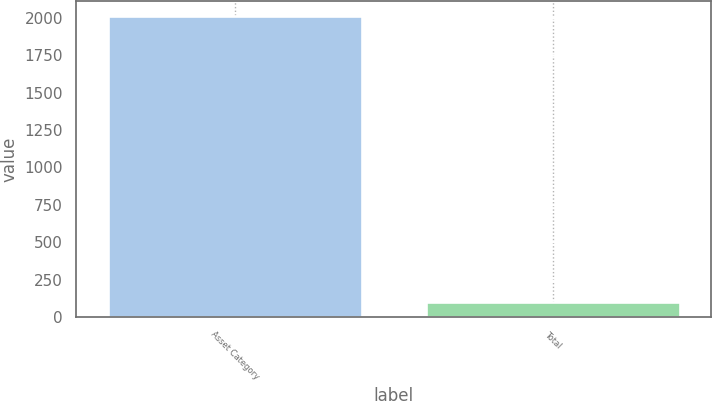<chart> <loc_0><loc_0><loc_500><loc_500><bar_chart><fcel>Asset Category<fcel>Total<nl><fcel>2011<fcel>100<nl></chart> 